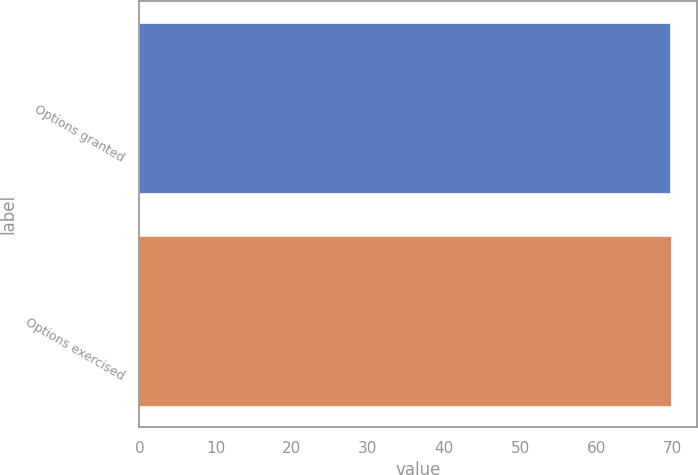<chart> <loc_0><loc_0><loc_500><loc_500><bar_chart><fcel>Options granted<fcel>Options exercised<nl><fcel>69.65<fcel>69.75<nl></chart> 